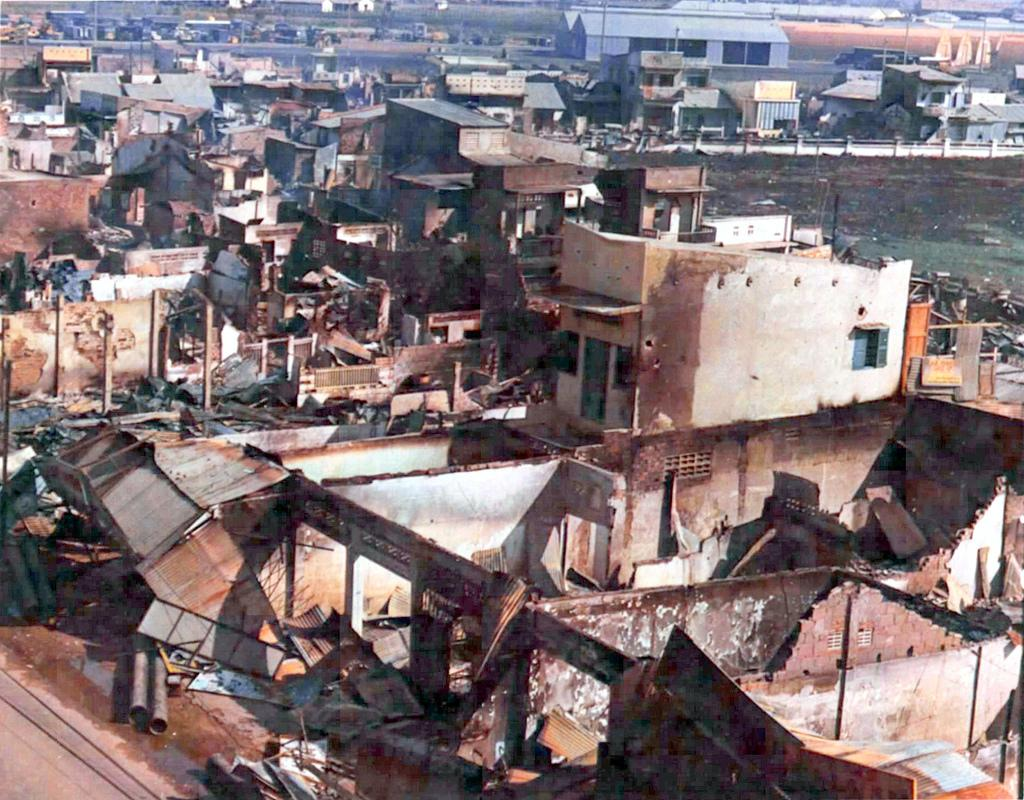What type of structures can be seen in the image? There are buildings in the image. Can you describe the condition of some of the buildings? Some of the buildings appear to be collapsed. What type of voice can be heard coming from the buildings in the image? There is no voice present in the image, as it is a still image of buildings. 